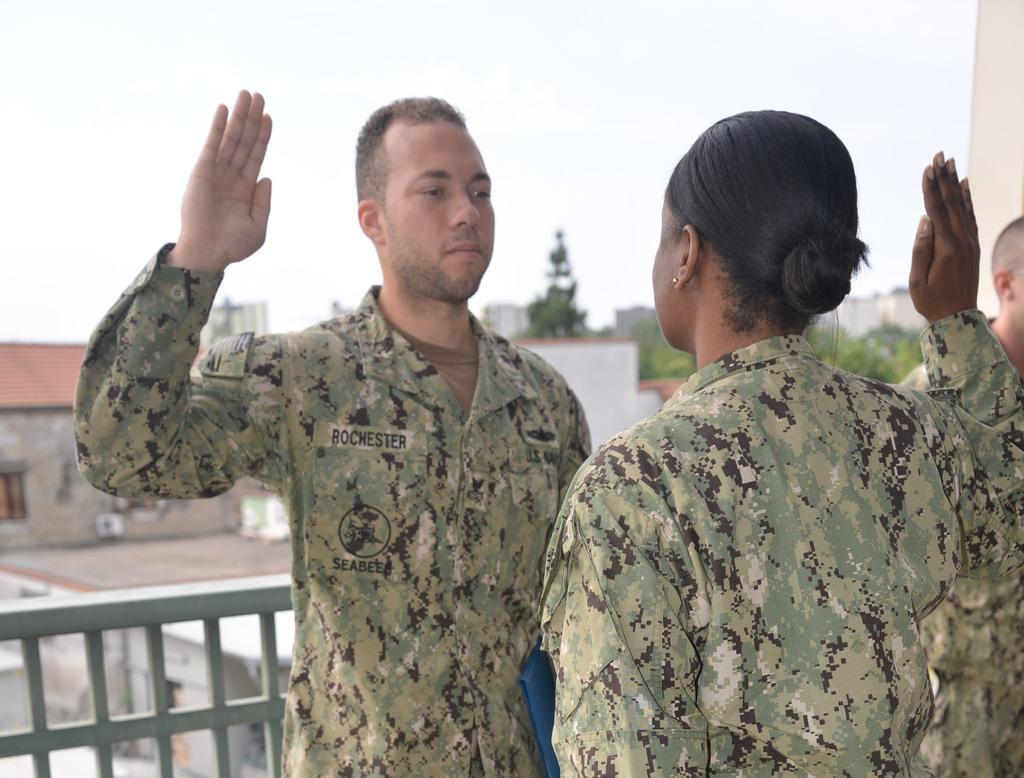How would you summarize this image in a sentence or two? In this picture I can see a woman and a man who are standing in front and I see that both of them are wearing uniforms and I see the railing behind this man. In the background I see the buildings and I see the sky and I see a person on the right side of the image. 